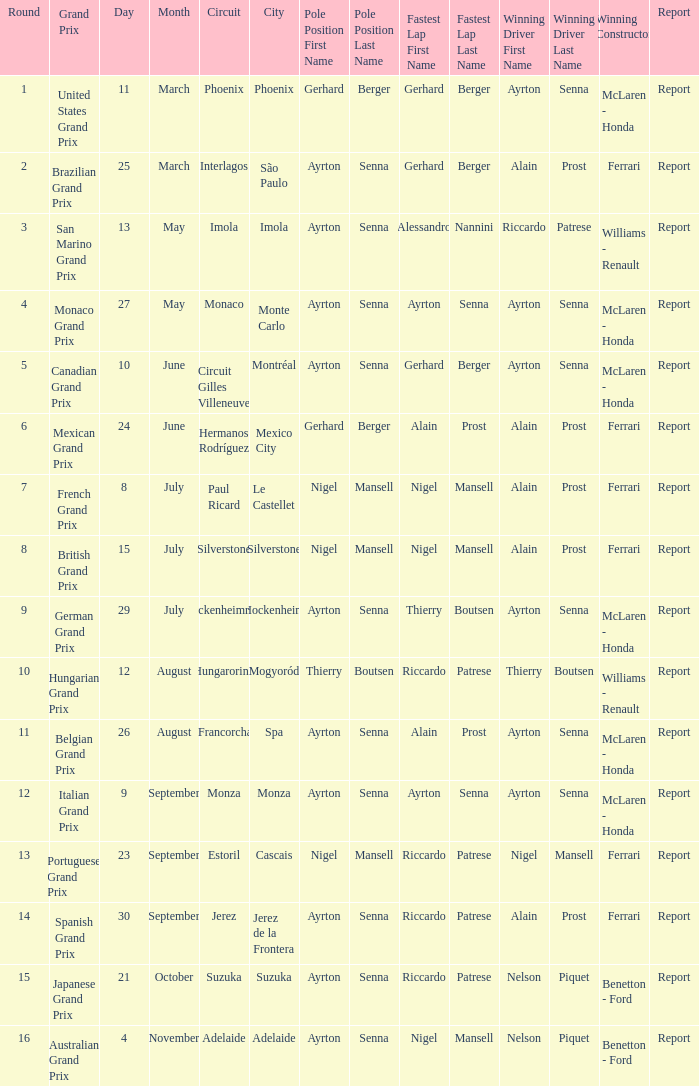What is the Pole Position for the German Grand Prix Ayrton Senna. 